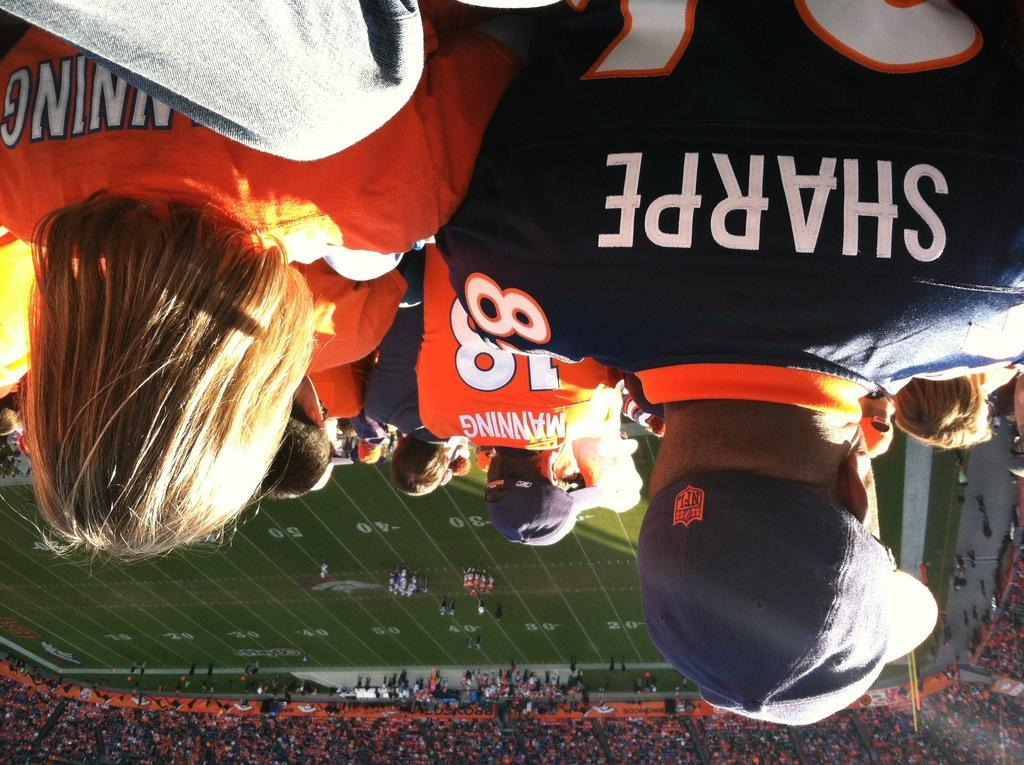What is happening at the top of the image? There is a group of people at the top of the image. What activity is taking place in the middle of the image? There are persons playing in the ground in the middle of the image. How many people are at the bottom of the image? There are a lot of people at the bottom of the image. What type of location is depicted in the image? The setting appears to be a stadium. Are there any ghosts visible in the image? There are no ghosts present in the image. What type of cable is being used by the players in the middle of the image? There is no cable visible in the image; the players are playing in a ground. 